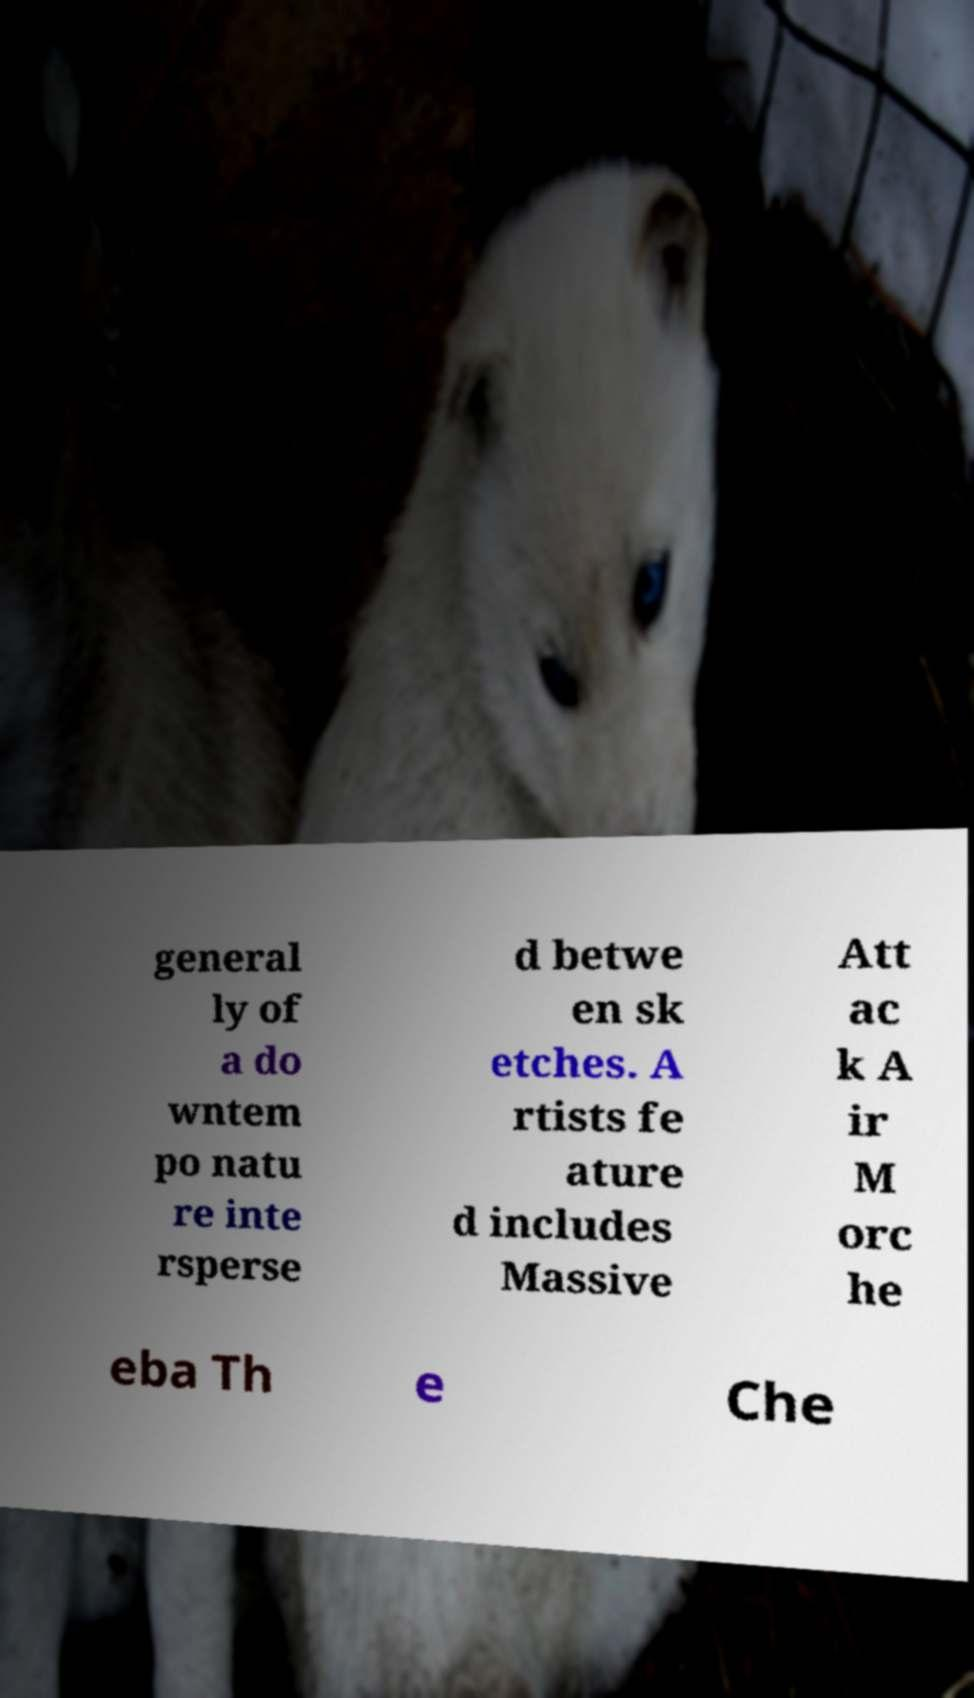What messages or text are displayed in this image? I need them in a readable, typed format. general ly of a do wntem po natu re inte rsperse d betwe en sk etches. A rtists fe ature d includes Massive Att ac k A ir M orc he eba Th e Che 